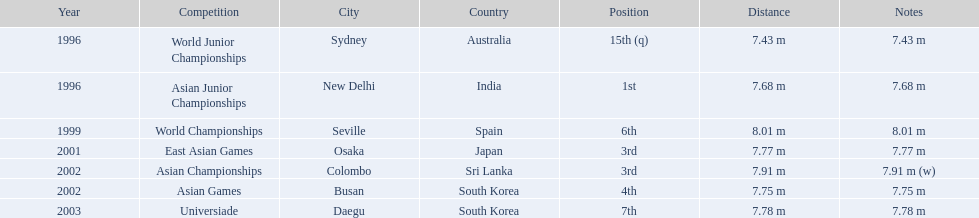What are all of the competitions? World Junior Championships, Asian Junior Championships, World Championships, East Asian Games, Asian Championships, Asian Games, Universiade. What was his positions in these competitions? 15th (q), 1st, 6th, 3rd, 3rd, 4th, 7th. And during which competition did he reach 1st place? Asian Junior Championships. 